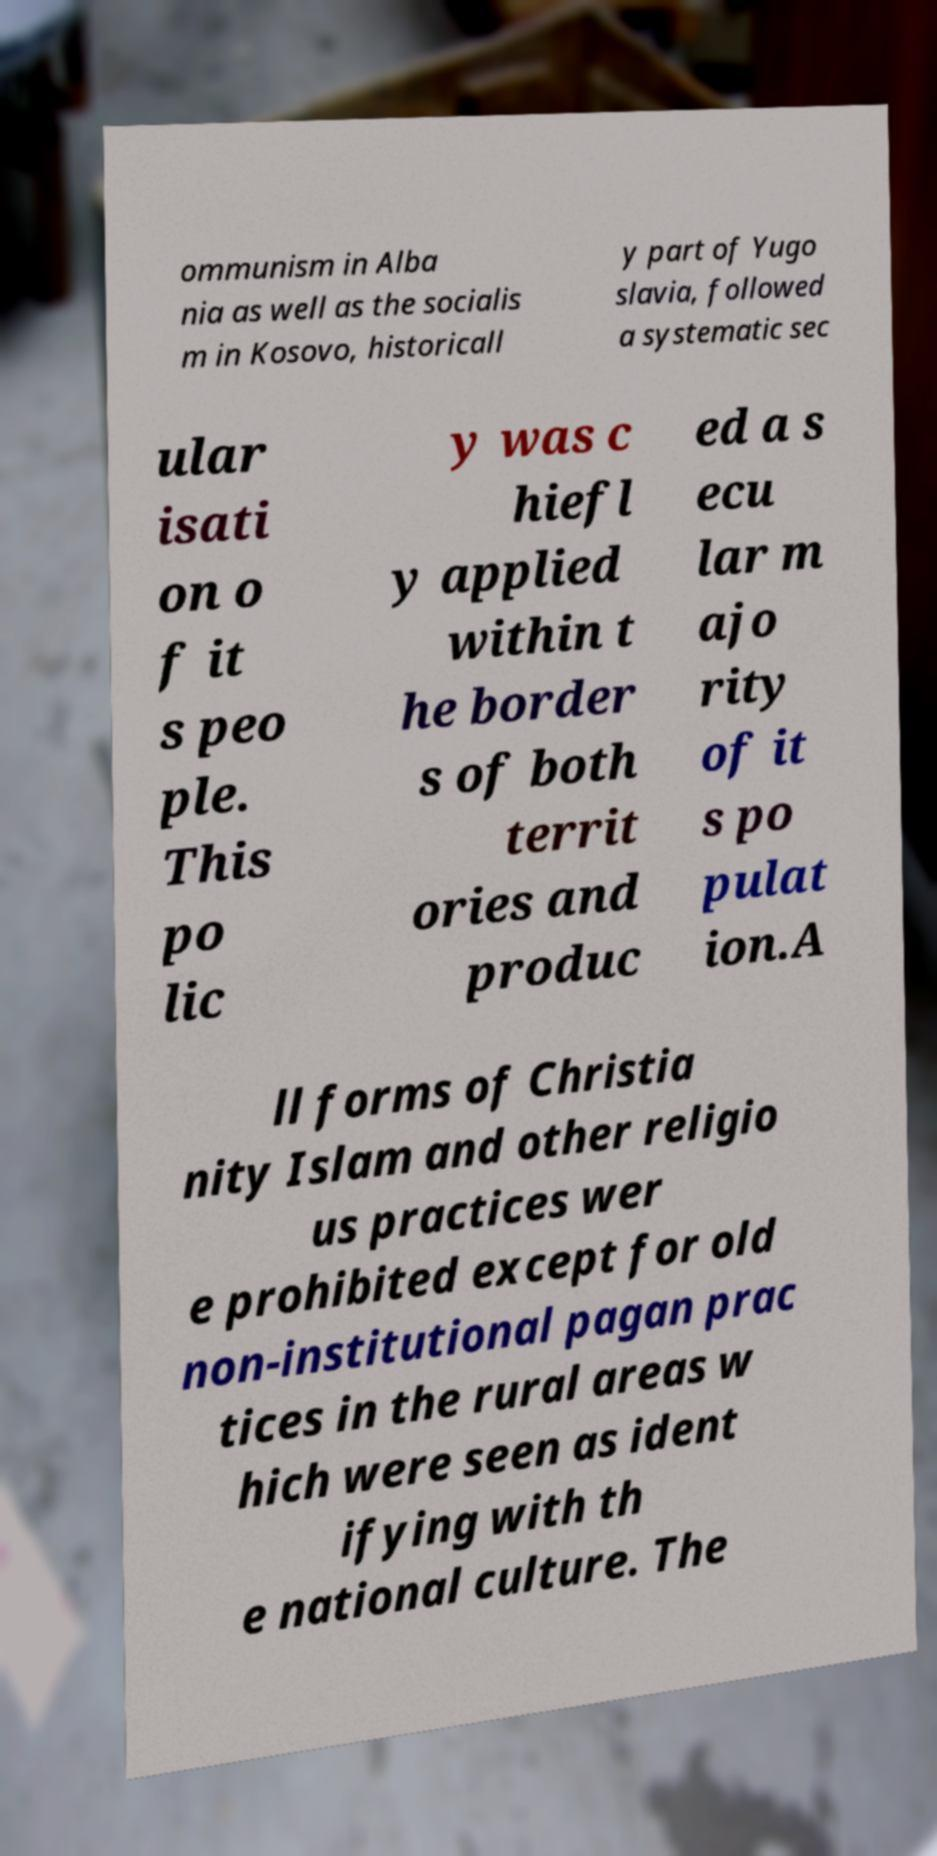What messages or text are displayed in this image? I need them in a readable, typed format. ommunism in Alba nia as well as the socialis m in Kosovo, historicall y part of Yugo slavia, followed a systematic sec ular isati on o f it s peo ple. This po lic y was c hiefl y applied within t he border s of both territ ories and produc ed a s ecu lar m ajo rity of it s po pulat ion.A ll forms of Christia nity Islam and other religio us practices wer e prohibited except for old non-institutional pagan prac tices in the rural areas w hich were seen as ident ifying with th e national culture. The 